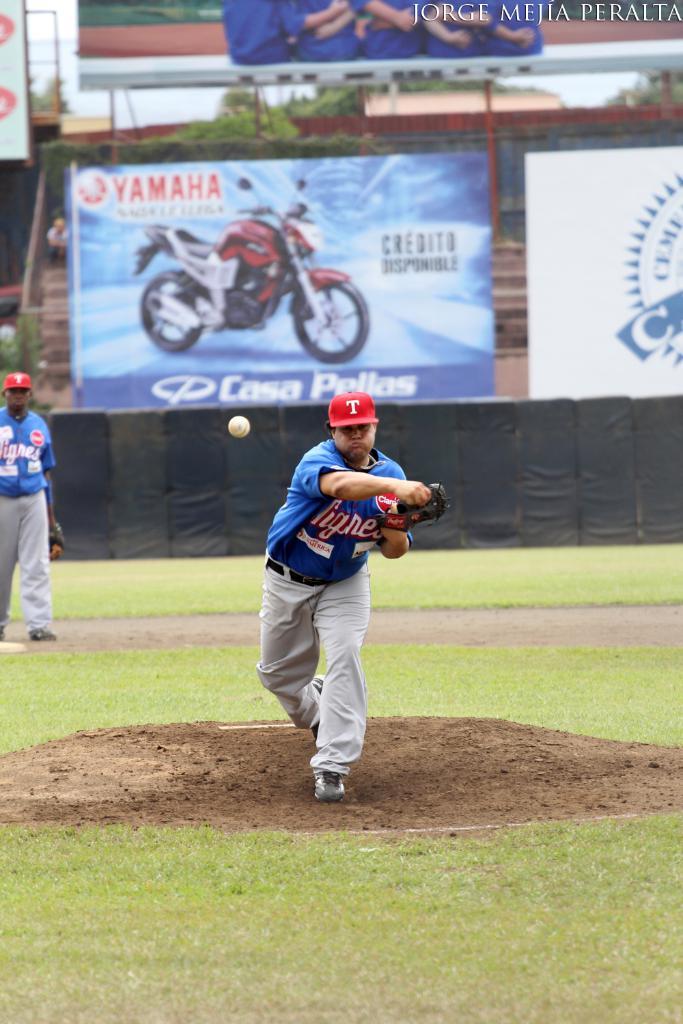What brand of motorbike is on the billboard?
Your answer should be compact. Yamaha. What letter is on his hat?
Make the answer very short. T. 